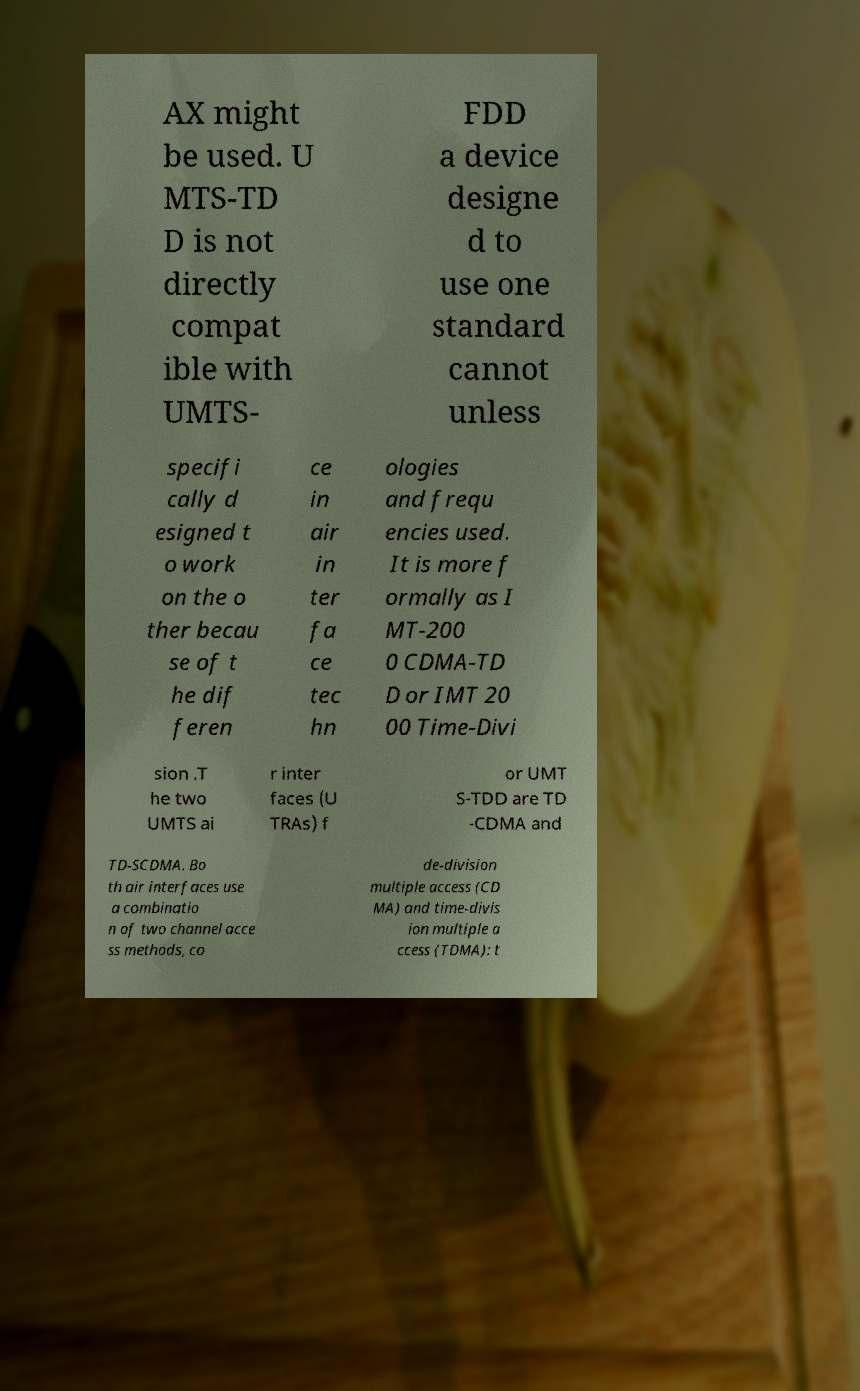Can you read and provide the text displayed in the image?This photo seems to have some interesting text. Can you extract and type it out for me? AX might be used. U MTS-TD D is not directly compat ible with UMTS- FDD a device designe d to use one standard cannot unless specifi cally d esigned t o work on the o ther becau se of t he dif feren ce in air in ter fa ce tec hn ologies and frequ encies used. It is more f ormally as I MT-200 0 CDMA-TD D or IMT 20 00 Time-Divi sion .T he two UMTS ai r inter faces (U TRAs) f or UMT S-TDD are TD -CDMA and TD-SCDMA. Bo th air interfaces use a combinatio n of two channel acce ss methods, co de-division multiple access (CD MA) and time-divis ion multiple a ccess (TDMA): t 